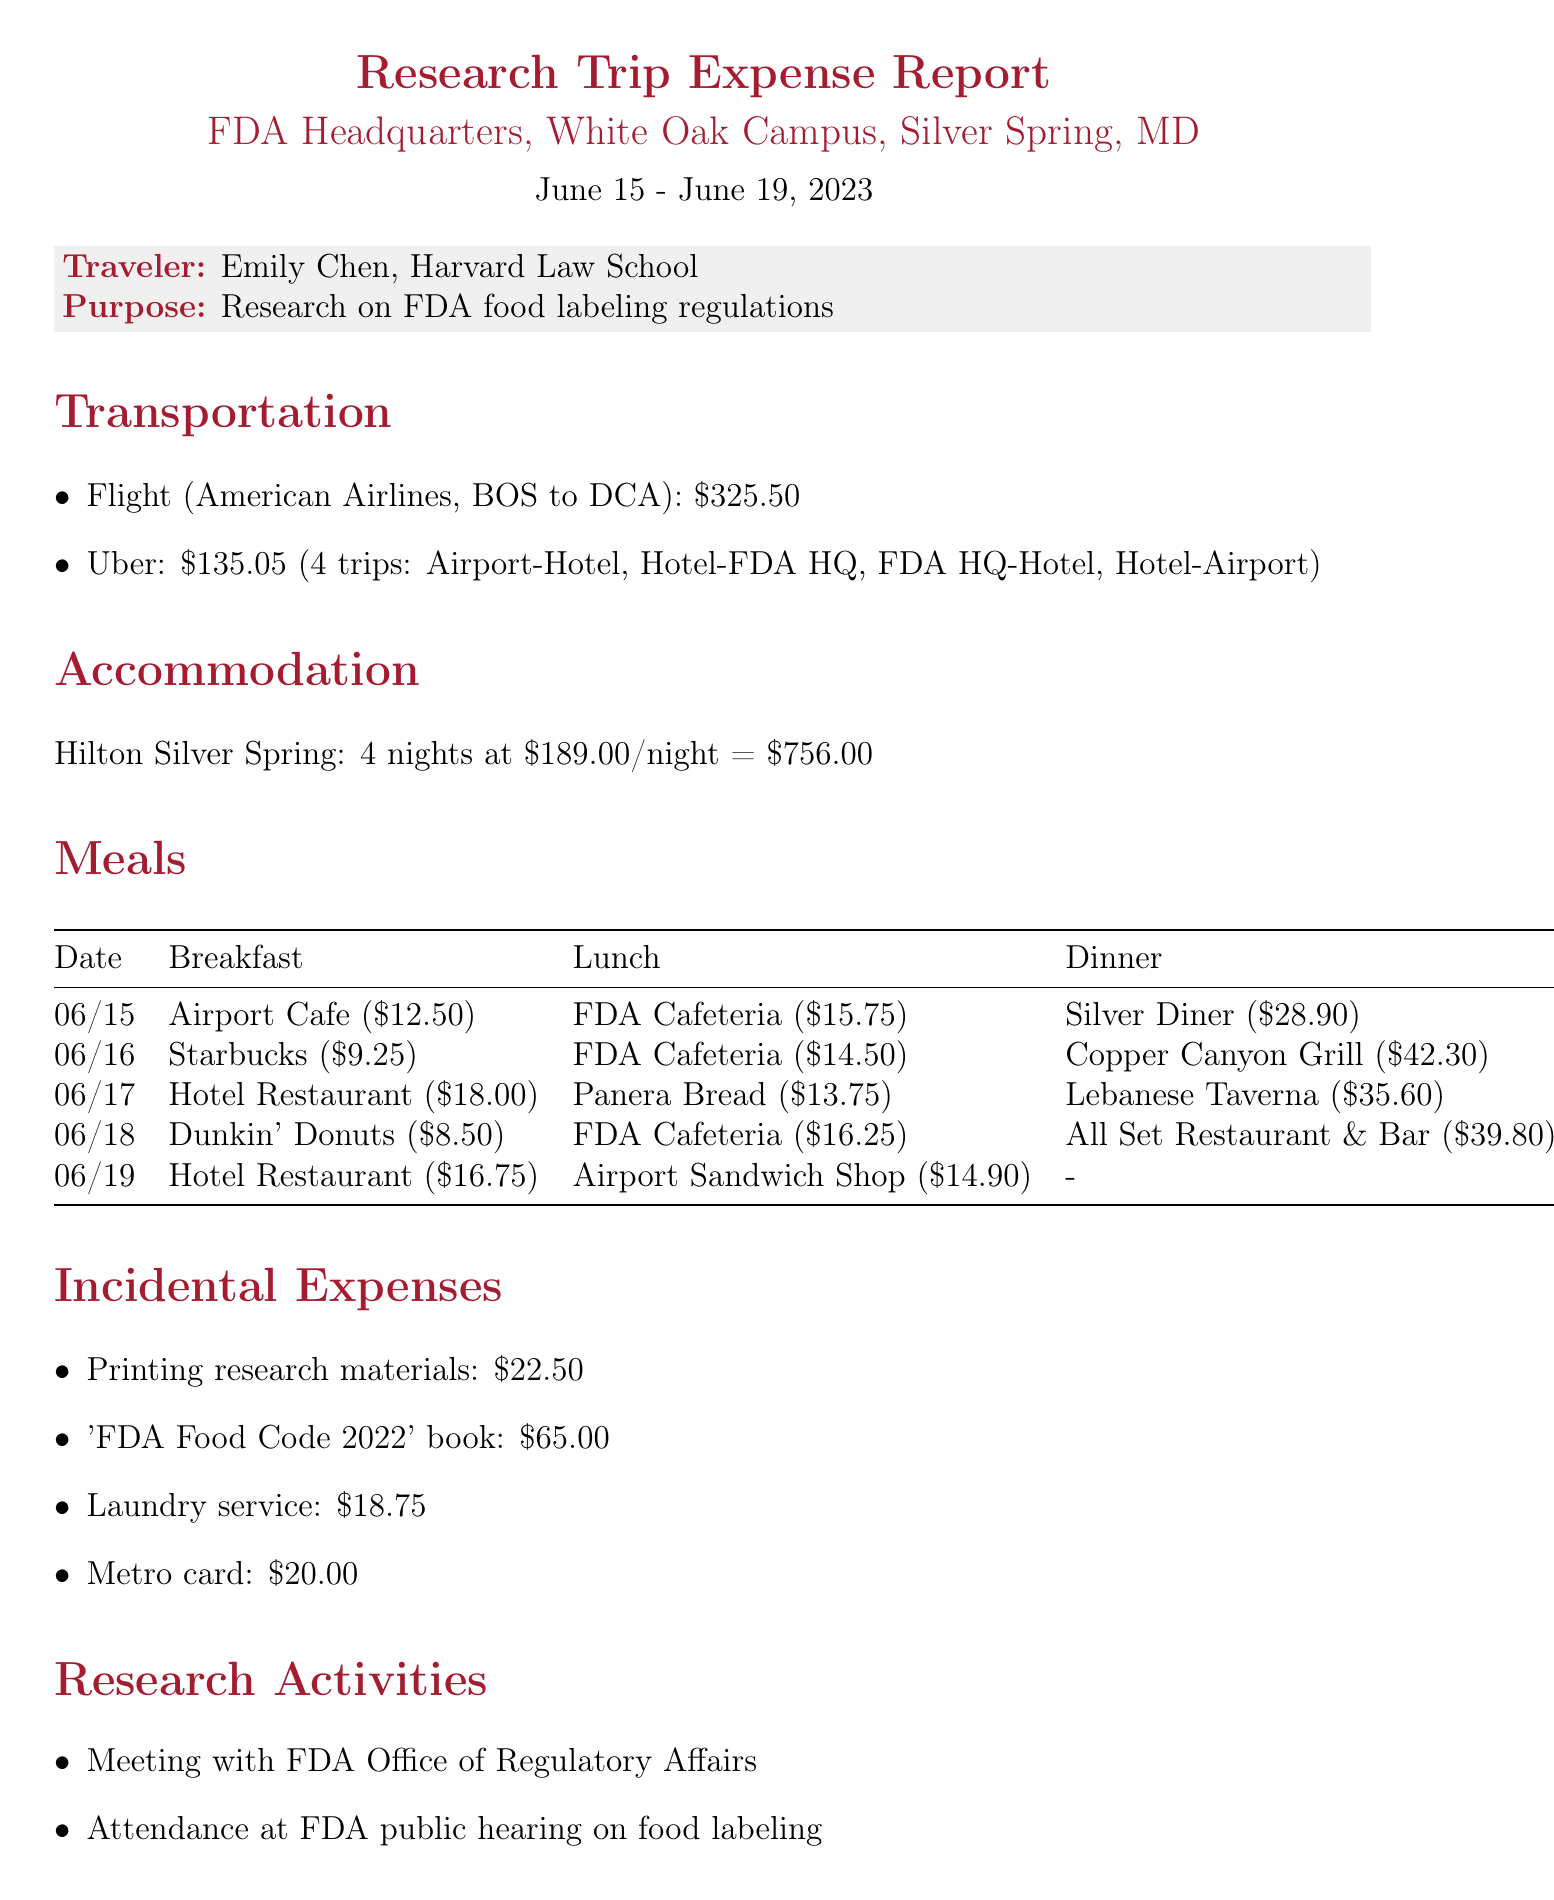What is the purpose of the trip? The purpose of the trip is indicated at the beginning of the document, specifically for research on food law regulations.
Answer: Research on FDA food labeling regulations Who is the traveler? The traveler is mentioned in the introduction section of the document.
Answer: Emily Chen, Harvard Law School What is the total cost of accommodation? The total cost of accommodation is calculated based on the number of nights and the cost per night provided in the document.
Answer: 756.00 How many nights did the traveler stay? The number of nights is directly specified in the accommodation section of the document.
Answer: 4 What was the cost of the flight? The cost of the flight is explicitly stated in the transportation section.
Answer: 325.50 Which restaurant did the traveler dine at for dinner on June 16? The document provides specific names of restaurants and their costs for each meal on each date.
Answer: Copper Canyon Grill What is the cost of the laundry service? The incidental expenses section lists costs for various items, including laundry service.
Answer: 18.75 How many research activities were listed? The document enumerates the research activities conducted by the traveler during the trip.
Answer: 4 What was the total amount of incidental expenses? The total incidental expenses can be deduced by summing the individual costs listed in that section of the document.
Answer: 126.25 